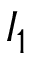<formula> <loc_0><loc_0><loc_500><loc_500>I _ { 1 }</formula> 